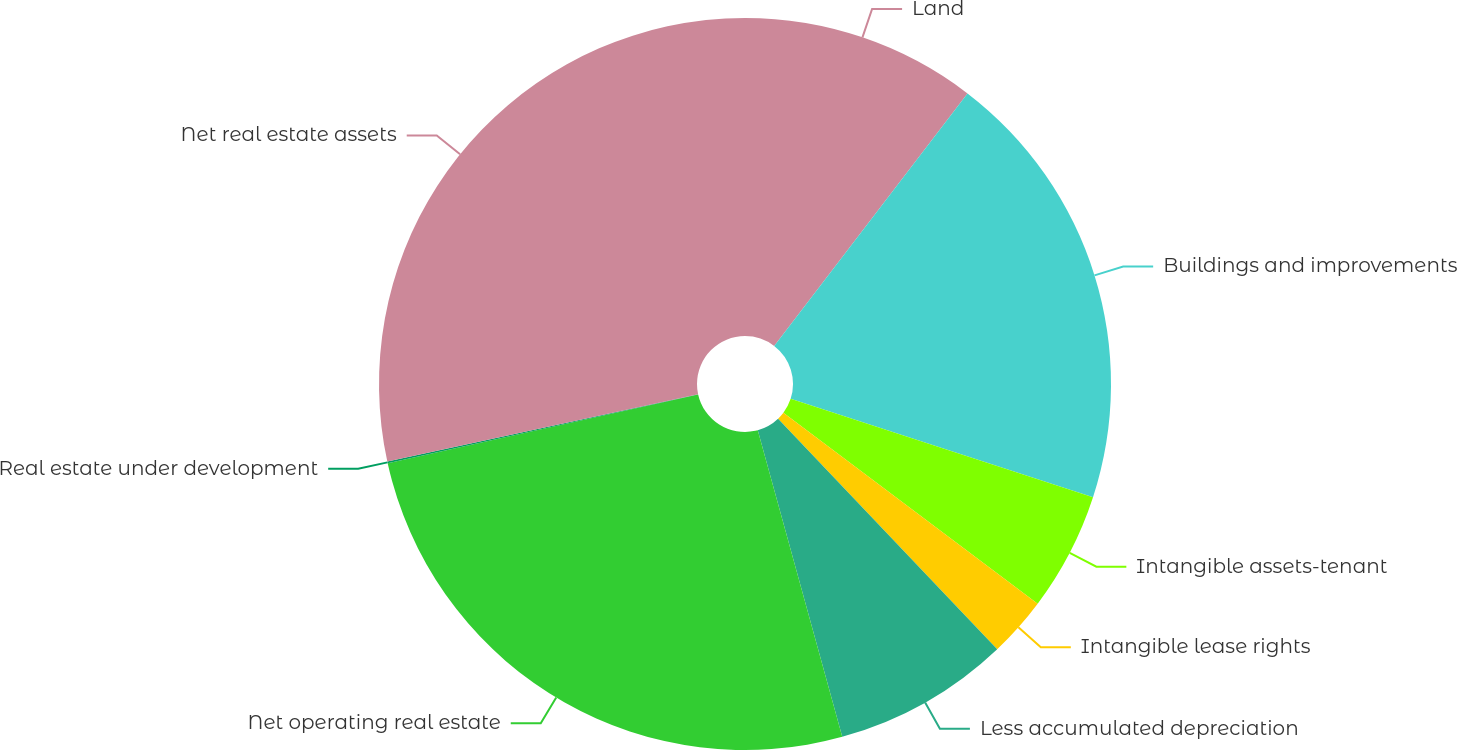Convert chart. <chart><loc_0><loc_0><loc_500><loc_500><pie_chart><fcel>Land<fcel>Buildings and improvements<fcel>Intangible assets-tenant<fcel>Intangible lease rights<fcel>Less accumulated depreciation<fcel>Net operating real estate<fcel>Real estate under development<fcel>Net real estate assets<nl><fcel>10.4%<fcel>19.61%<fcel>5.24%<fcel>2.65%<fcel>7.82%<fcel>25.81%<fcel>0.07%<fcel>28.4%<nl></chart> 